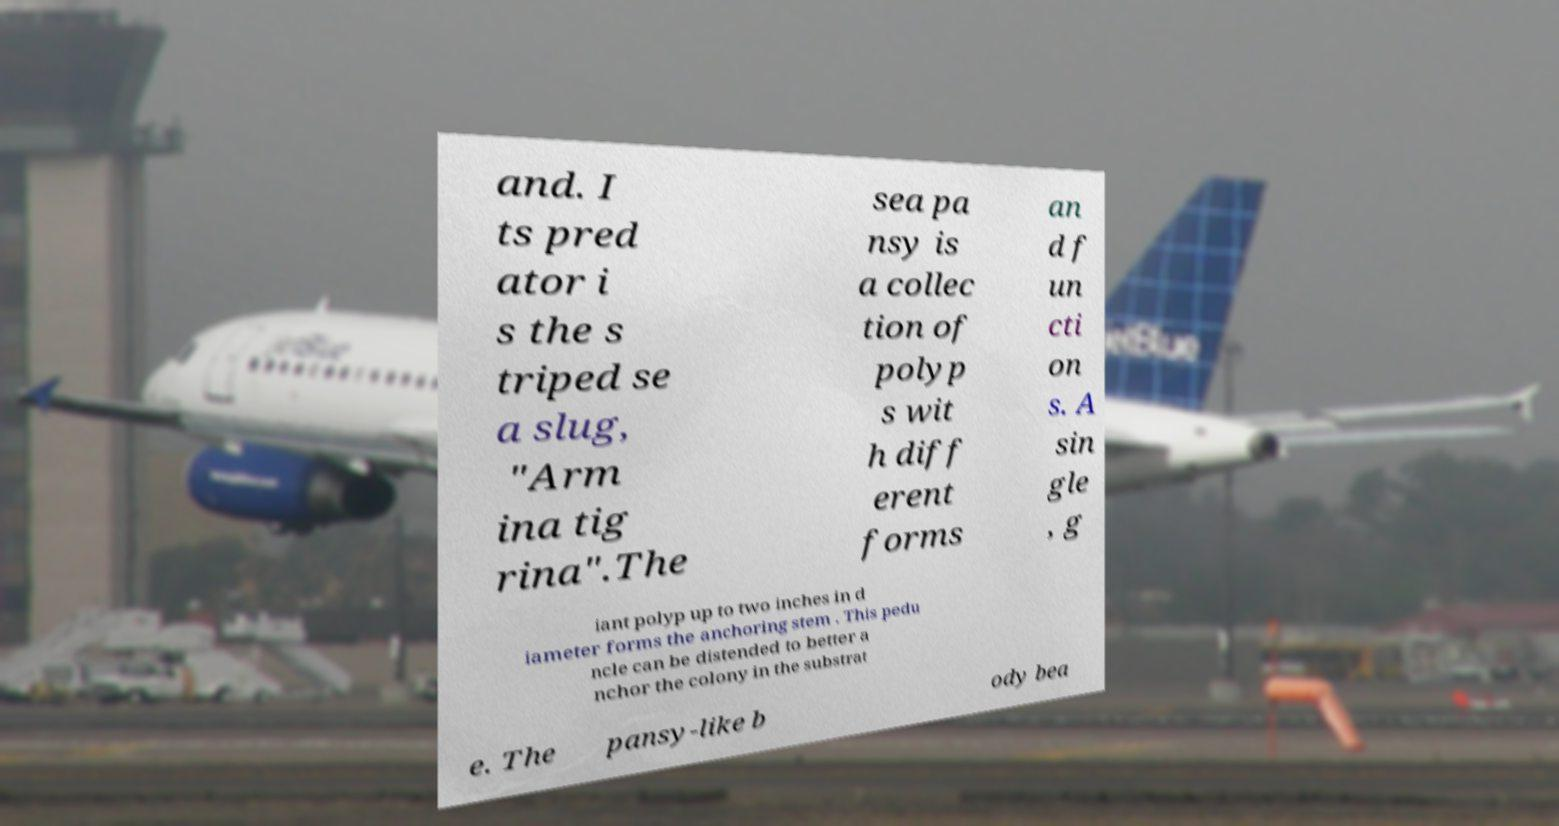Please identify and transcribe the text found in this image. and. I ts pred ator i s the s triped se a slug, "Arm ina tig rina".The sea pa nsy is a collec tion of polyp s wit h diff erent forms an d f un cti on s. A sin gle , g iant polyp up to two inches in d iameter forms the anchoring stem . This pedu ncle can be distended to better a nchor the colony in the substrat e. The pansy-like b ody bea 